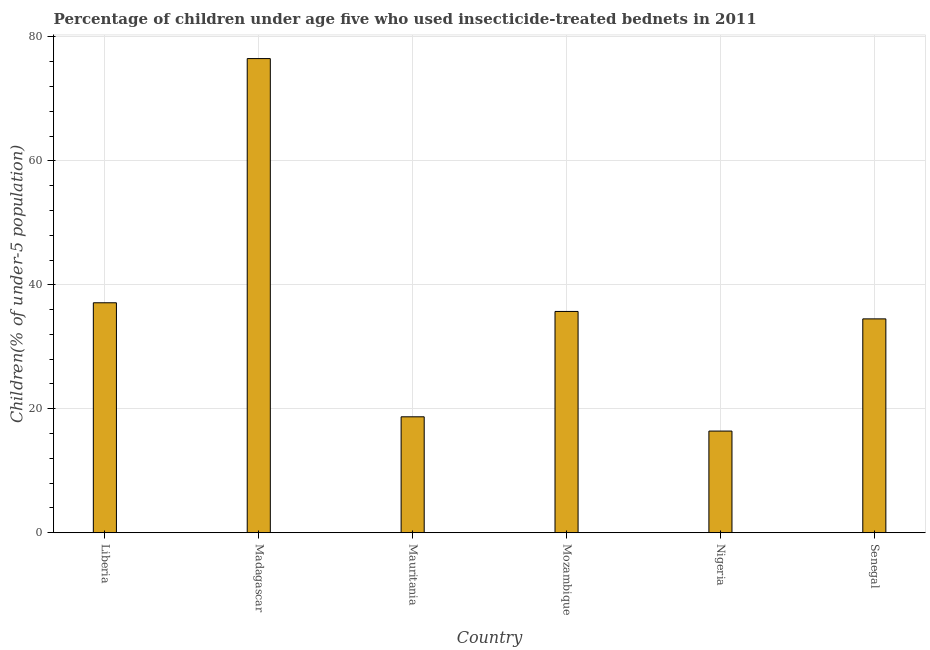Does the graph contain any zero values?
Offer a very short reply. No. What is the title of the graph?
Offer a terse response. Percentage of children under age five who used insecticide-treated bednets in 2011. What is the label or title of the Y-axis?
Your answer should be compact. Children(% of under-5 population). What is the percentage of children who use of insecticide-treated bed nets in Mozambique?
Give a very brief answer. 35.7. Across all countries, what is the maximum percentage of children who use of insecticide-treated bed nets?
Offer a very short reply. 76.5. In which country was the percentage of children who use of insecticide-treated bed nets maximum?
Ensure brevity in your answer.  Madagascar. In which country was the percentage of children who use of insecticide-treated bed nets minimum?
Offer a very short reply. Nigeria. What is the sum of the percentage of children who use of insecticide-treated bed nets?
Offer a very short reply. 218.9. What is the difference between the percentage of children who use of insecticide-treated bed nets in Mauritania and Senegal?
Offer a terse response. -15.8. What is the average percentage of children who use of insecticide-treated bed nets per country?
Provide a succinct answer. 36.48. What is the median percentage of children who use of insecticide-treated bed nets?
Offer a very short reply. 35.1. What is the ratio of the percentage of children who use of insecticide-treated bed nets in Mauritania to that in Nigeria?
Your answer should be very brief. 1.14. Is the difference between the percentage of children who use of insecticide-treated bed nets in Nigeria and Senegal greater than the difference between any two countries?
Make the answer very short. No. What is the difference between the highest and the second highest percentage of children who use of insecticide-treated bed nets?
Keep it short and to the point. 39.4. Is the sum of the percentage of children who use of insecticide-treated bed nets in Liberia and Mauritania greater than the maximum percentage of children who use of insecticide-treated bed nets across all countries?
Ensure brevity in your answer.  No. What is the difference between the highest and the lowest percentage of children who use of insecticide-treated bed nets?
Offer a terse response. 60.1. In how many countries, is the percentage of children who use of insecticide-treated bed nets greater than the average percentage of children who use of insecticide-treated bed nets taken over all countries?
Provide a succinct answer. 2. Are all the bars in the graph horizontal?
Provide a succinct answer. No. How many countries are there in the graph?
Your answer should be very brief. 6. What is the difference between two consecutive major ticks on the Y-axis?
Make the answer very short. 20. What is the Children(% of under-5 population) in Liberia?
Your answer should be compact. 37.1. What is the Children(% of under-5 population) in Madagascar?
Offer a terse response. 76.5. What is the Children(% of under-5 population) in Mauritania?
Ensure brevity in your answer.  18.7. What is the Children(% of under-5 population) in Mozambique?
Your answer should be compact. 35.7. What is the Children(% of under-5 population) of Nigeria?
Make the answer very short. 16.4. What is the Children(% of under-5 population) of Senegal?
Keep it short and to the point. 34.5. What is the difference between the Children(% of under-5 population) in Liberia and Madagascar?
Provide a succinct answer. -39.4. What is the difference between the Children(% of under-5 population) in Liberia and Mauritania?
Ensure brevity in your answer.  18.4. What is the difference between the Children(% of under-5 population) in Liberia and Mozambique?
Provide a short and direct response. 1.4. What is the difference between the Children(% of under-5 population) in Liberia and Nigeria?
Provide a succinct answer. 20.7. What is the difference between the Children(% of under-5 population) in Madagascar and Mauritania?
Offer a terse response. 57.8. What is the difference between the Children(% of under-5 population) in Madagascar and Mozambique?
Give a very brief answer. 40.8. What is the difference between the Children(% of under-5 population) in Madagascar and Nigeria?
Keep it short and to the point. 60.1. What is the difference between the Children(% of under-5 population) in Madagascar and Senegal?
Offer a very short reply. 42. What is the difference between the Children(% of under-5 population) in Mauritania and Senegal?
Make the answer very short. -15.8. What is the difference between the Children(% of under-5 population) in Mozambique and Nigeria?
Your answer should be compact. 19.3. What is the difference between the Children(% of under-5 population) in Mozambique and Senegal?
Keep it short and to the point. 1.2. What is the difference between the Children(% of under-5 population) in Nigeria and Senegal?
Give a very brief answer. -18.1. What is the ratio of the Children(% of under-5 population) in Liberia to that in Madagascar?
Your answer should be very brief. 0.48. What is the ratio of the Children(% of under-5 population) in Liberia to that in Mauritania?
Make the answer very short. 1.98. What is the ratio of the Children(% of under-5 population) in Liberia to that in Mozambique?
Give a very brief answer. 1.04. What is the ratio of the Children(% of under-5 population) in Liberia to that in Nigeria?
Your response must be concise. 2.26. What is the ratio of the Children(% of under-5 population) in Liberia to that in Senegal?
Provide a short and direct response. 1.07. What is the ratio of the Children(% of under-5 population) in Madagascar to that in Mauritania?
Ensure brevity in your answer.  4.09. What is the ratio of the Children(% of under-5 population) in Madagascar to that in Mozambique?
Provide a short and direct response. 2.14. What is the ratio of the Children(% of under-5 population) in Madagascar to that in Nigeria?
Offer a terse response. 4.67. What is the ratio of the Children(% of under-5 population) in Madagascar to that in Senegal?
Your answer should be compact. 2.22. What is the ratio of the Children(% of under-5 population) in Mauritania to that in Mozambique?
Keep it short and to the point. 0.52. What is the ratio of the Children(% of under-5 population) in Mauritania to that in Nigeria?
Your answer should be compact. 1.14. What is the ratio of the Children(% of under-5 population) in Mauritania to that in Senegal?
Your answer should be very brief. 0.54. What is the ratio of the Children(% of under-5 population) in Mozambique to that in Nigeria?
Offer a very short reply. 2.18. What is the ratio of the Children(% of under-5 population) in Mozambique to that in Senegal?
Make the answer very short. 1.03. What is the ratio of the Children(% of under-5 population) in Nigeria to that in Senegal?
Ensure brevity in your answer.  0.47. 